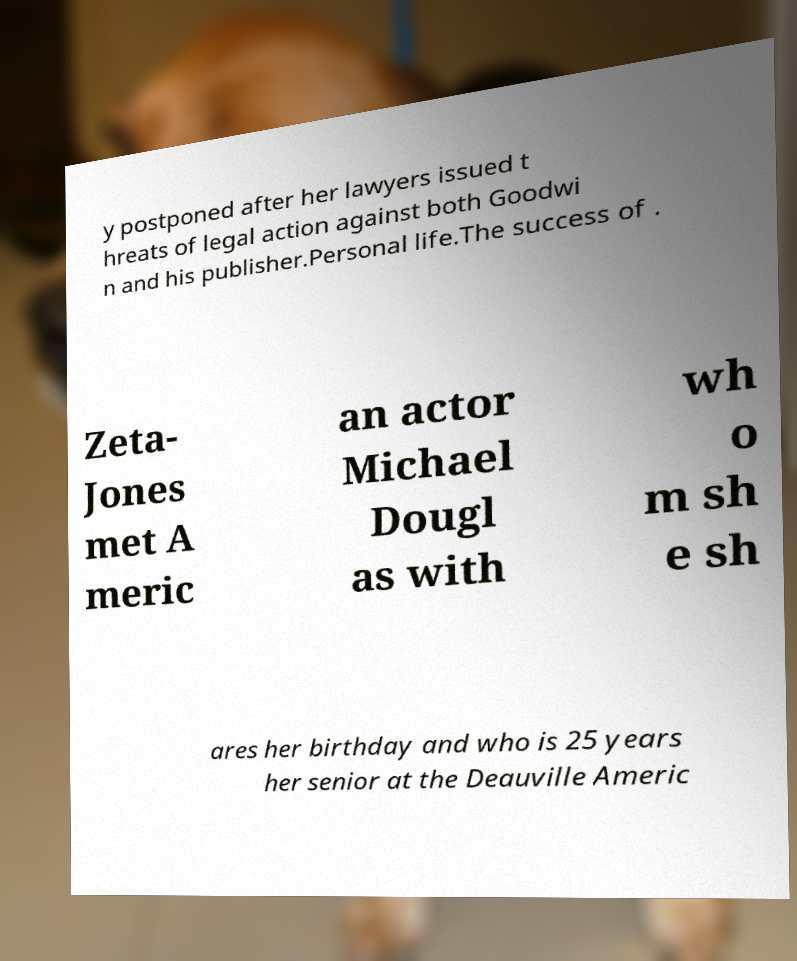Please identify and transcribe the text found in this image. y postponed after her lawyers issued t hreats of legal action against both Goodwi n and his publisher.Personal life.The success of . Zeta- Jones met A meric an actor Michael Dougl as with wh o m sh e sh ares her birthday and who is 25 years her senior at the Deauville Americ 